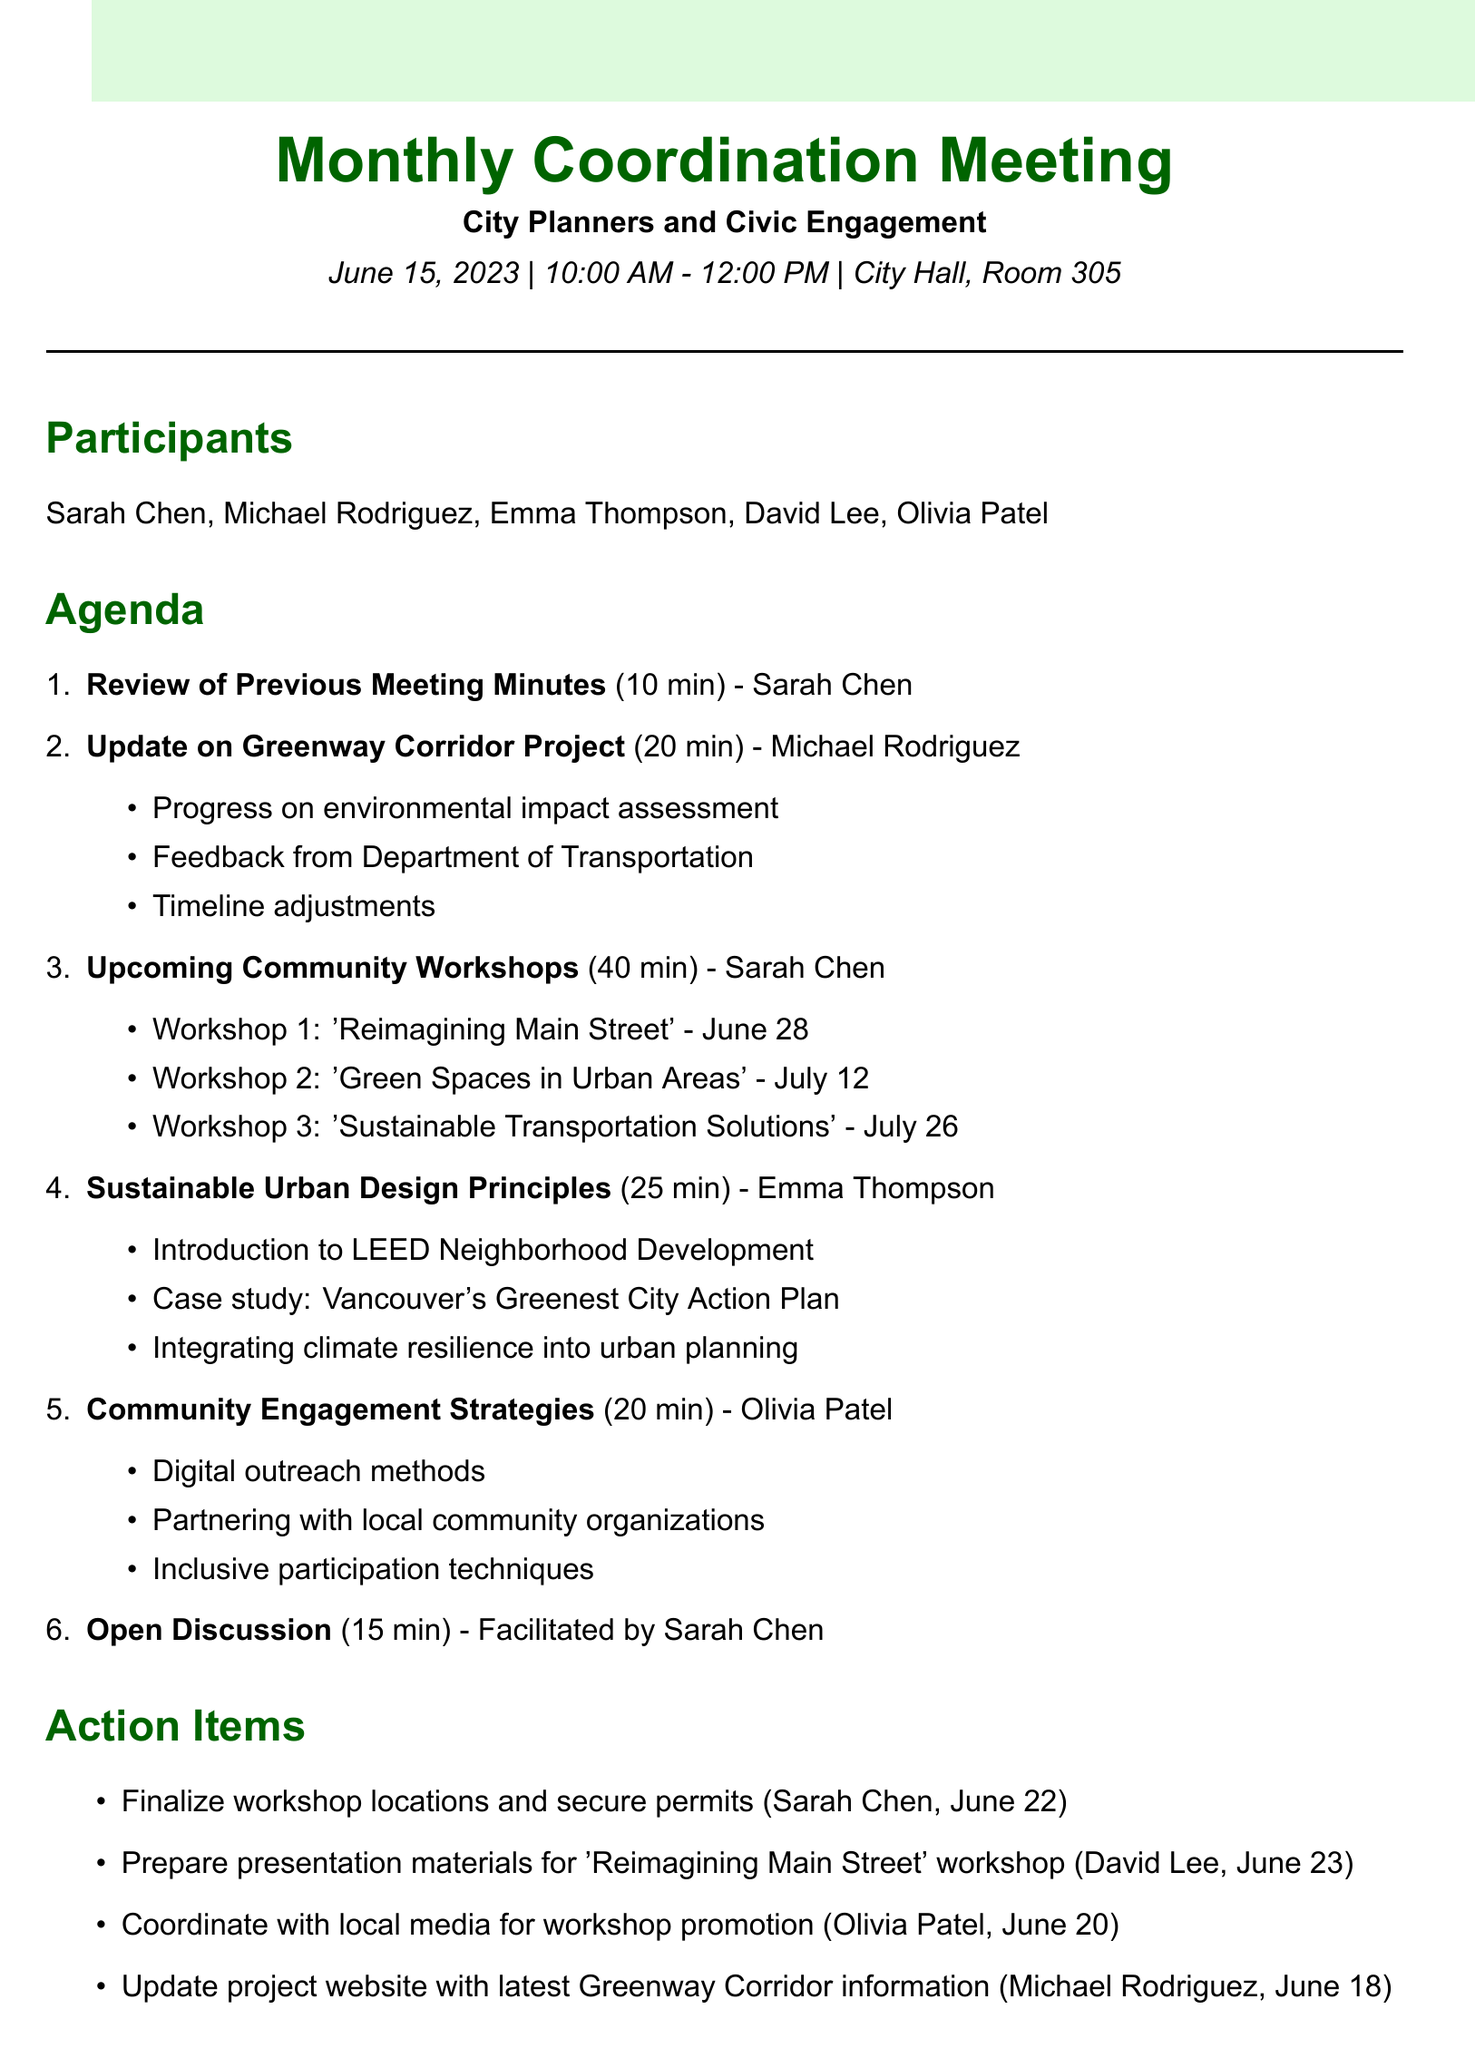what is the date of the meeting? The date of the meeting is specified in the meeting details section.
Answer: June 15, 2023 who is the presenter for the 'Upcoming Community Workshops' agenda item? The presenter is mentioned alongside each agenda item, including the 'Upcoming Community Workshops.'
Answer: Sarah Chen how long is the 'Sustainable Urban Design Principles' presentation scheduled for? The duration is clearly indicated in the agenda item title.
Answer: 25 minutes what is the deadline for finalizing workshop locations? The deadline is stated in the action items section under tasks.
Answer: June 22, 2023 what topics will be covered in the first community workshop? The subtopics listed provide details on the content of the workshop.
Answer: 'Reimagining Main Street' how many participants are listed in the meeting details? The number of participants can be counted from the list provided in the document.
Answer: 5 which agenda item has the most time allocated? The duration of each agenda item indicates the one with the most time.
Answer: Upcoming Community Workshops who is responsible for promoting the workshops with local media? The actions and assigned persons are indicated in the action items section.
Answer: Olivia Patel which resource focuses on sustainable cities and communities? The titles of additional resources provide insights into their focus areas.
Answer: UN Sustainable Development Goals - Goal 11: Sustainable Cities and Communities 